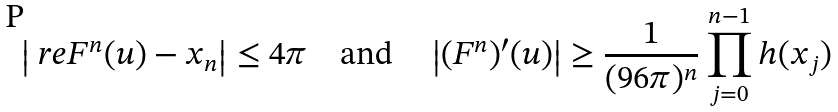<formula> <loc_0><loc_0><loc_500><loc_500>\left | \ r e F ^ { n } ( u ) - x _ { n } \right | \leq 4 \pi \quad \text {and} \quad \left | ( F ^ { n } ) ^ { \prime } ( u ) \right | \geq \frac { 1 } { ( 9 6 \pi ) ^ { n } } \prod _ { j = 0 } ^ { n - 1 } h ( x _ { j } )</formula> 